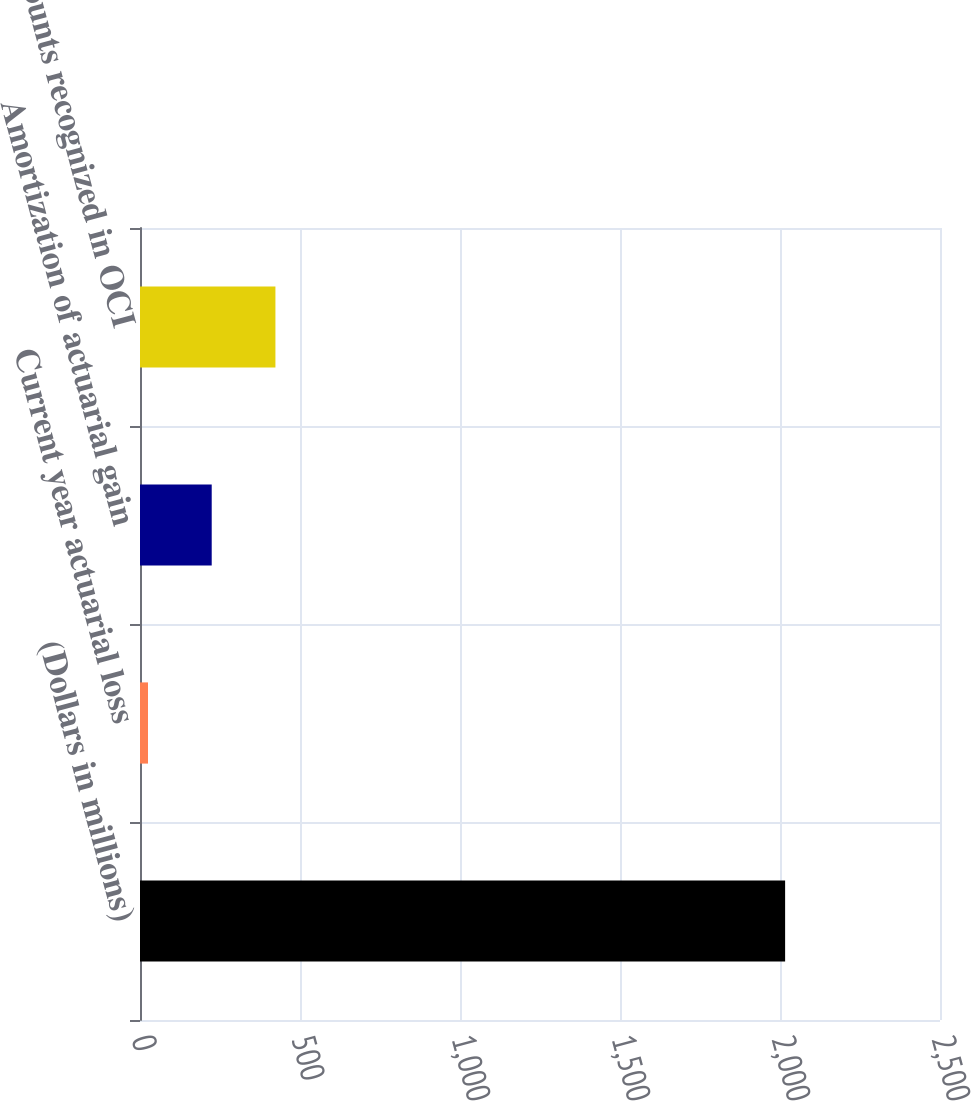Convert chart to OTSL. <chart><loc_0><loc_0><loc_500><loc_500><bar_chart><fcel>(Dollars in millions)<fcel>Current year actuarial loss<fcel>Amortization of actuarial gain<fcel>Amounts recognized in OCI<nl><fcel>2016<fcel>25<fcel>224.1<fcel>423.2<nl></chart> 